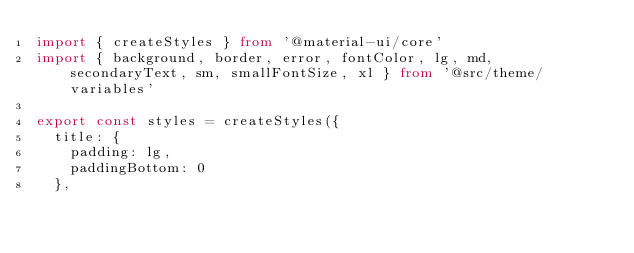Convert code to text. <code><loc_0><loc_0><loc_500><loc_500><_TypeScript_>import { createStyles } from '@material-ui/core'
import { background, border, error, fontColor, lg, md, secondaryText, sm, smallFontSize, xl } from '@src/theme/variables'

export const styles = createStyles({
  title: {
    padding: lg,
    paddingBottom: 0
  },</code> 